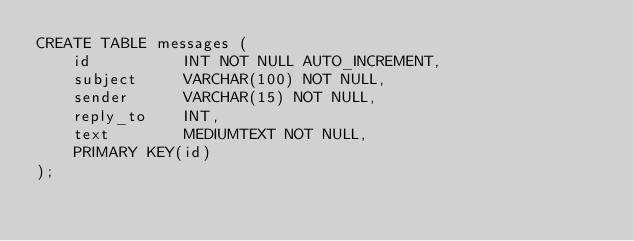<code> <loc_0><loc_0><loc_500><loc_500><_SQL_>CREATE TABLE messages (
    id          INT NOT NULL AUTO_INCREMENT,
    subject     VARCHAR(100) NOT NULL,
    sender      VARCHAR(15) NOT NULL,
    reply_to    INT,
    text        MEDIUMTEXT NOT NULL,
    PRIMARY KEY(id)
);</code> 